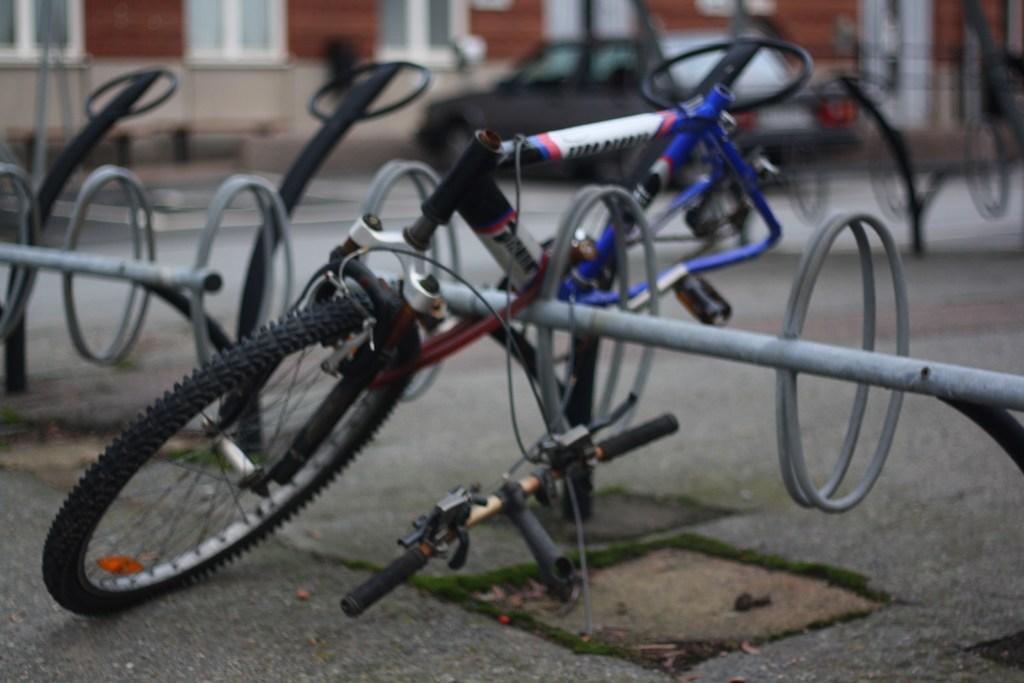In one or two sentences, can you explain what this image depicts? In this image we can see the spare parts of bicycle on the floor. 